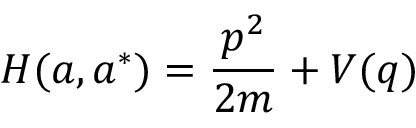Convert formula to latex. <formula><loc_0><loc_0><loc_500><loc_500>H ( a , a ^ { * } ) = { \frac { p ^ { 2 } } { 2 m } } + V ( q )</formula> 